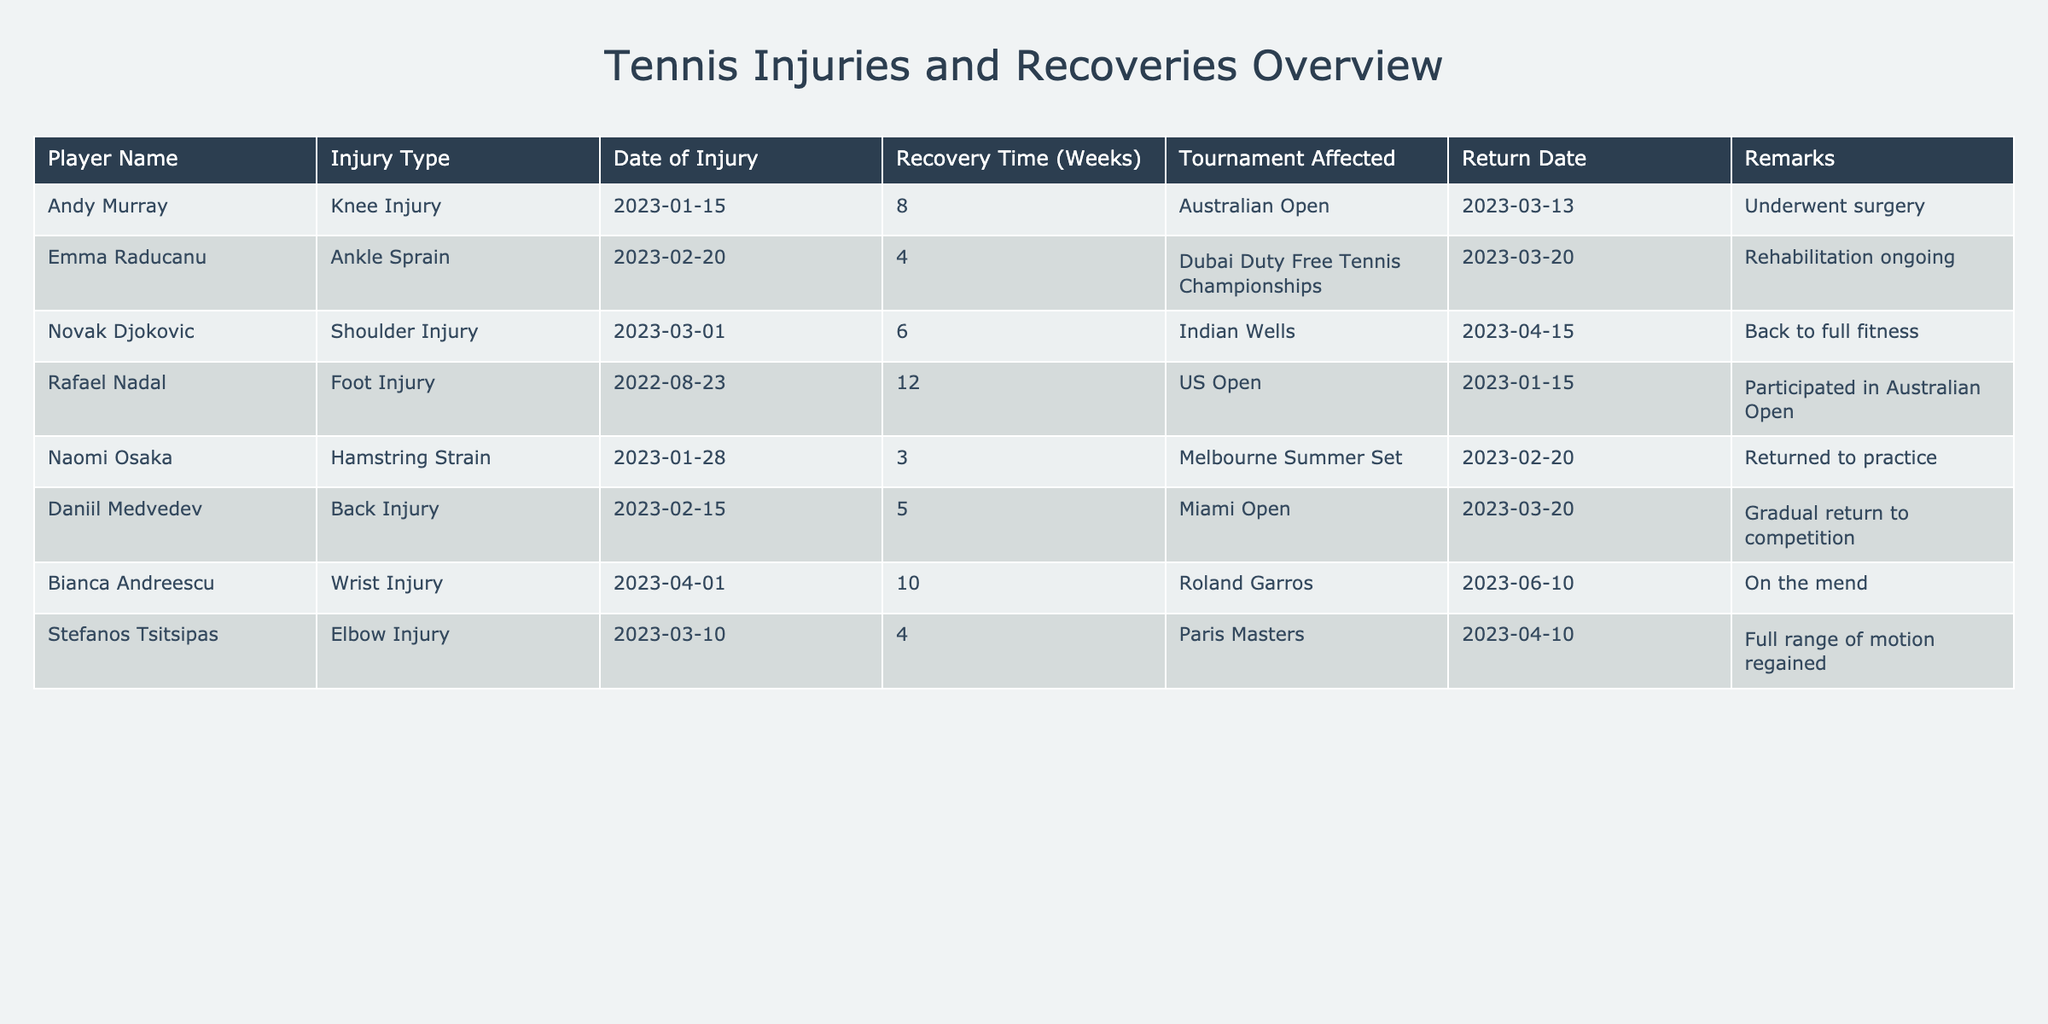What is the longest recovery time recorded in the table? The longest recovery time recorded is for Rafael Nadal, who had a recovery time of 12 weeks due to a foot injury.
Answer: 12 weeks Which player returned on March 20, 2023? Two players returned on this date: Emma Raducanu and Daniil Medvedev. Emma Raducanu had an ankle sprain, and Daniil Medvedev suffered a back injury.
Answer: Emma Raducanu and Daniil Medvedev Did any player undergo surgery? Yes, Andy Murray underwent surgery for his knee injury.
Answer: Yes What is the average recovery time for the players listed in the table? To calculate the average recovery time, we sum the recovery times: 8 + 4 + 6 + 12 + 3 + 5 + 10 + 4 = 52 weeks, and since there are 8 players, we divide by 8: 52/8 = 6.5 weeks.
Answer: 6.5 weeks Which injury type had the shortest recovery time, and who was affected? The shortest recovery time was 3 weeks, which affected Naomi Osaka due to a hamstring strain.
Answer: Hamstring strain by Naomi Osaka How many players had an injury that affected the Australian Open? Two players had injuries that affected the Australian Open: Andy Murray with a knee injury and Rafael Nadal with a foot injury.
Answer: 2 players Is there any player who returned to practice before their scheduled recovery date? Yes, Naomi Osaka returned to practice on February 20, 2023, which is earlier than her 3-week recovery period.
Answer: Yes Who experienced a wrist injury and when did they recover? Bianca Andreescu experienced a wrist injury, and her recovery date was June 10, 2023, indicating a recovery period of 10 weeks.
Answer: Bianca Andreescu, June 10, 2023 What was the tournament affected by the elbow injury sustained by Stefanos Tsitsipas? The tournament affected by Stefanos Tsitsipas's elbow injury was the Paris Masters.
Answer: Paris Masters 